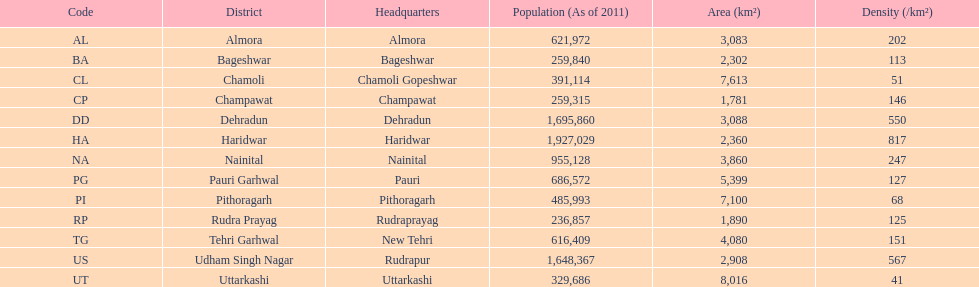What are the density measurements for the districts in uttarakhand? 202, 113, 51, 146, 550, 817, 247, 127, 68, 125, 151, 567, 41. Which district possesses a value of 51? Chamoli. 